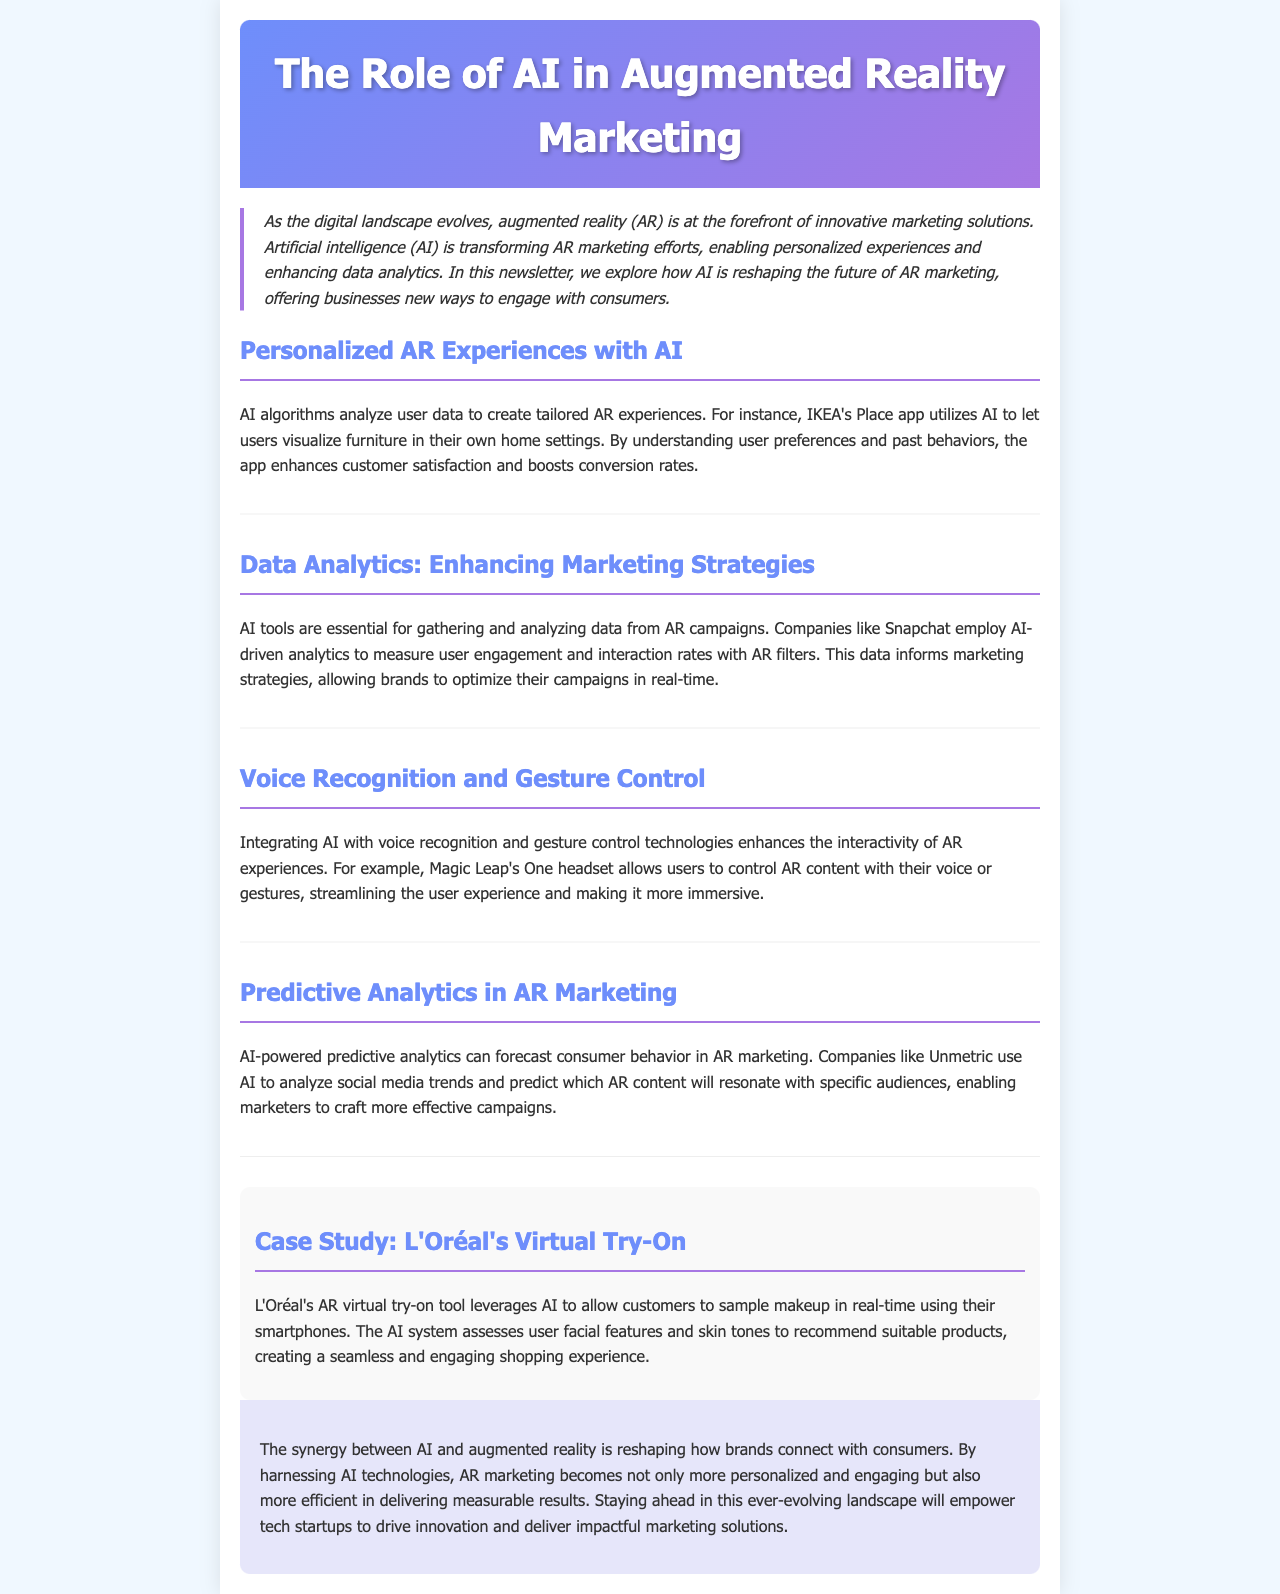What is the title of the newsletter? The title of the newsletter is presented in the header section of the document.
Answer: The Role of AI in Augmented Reality Marketing What app does IKEA utilize for personalized AR experiences? The document mentions that IKEA's Place app uses AI for creating tailored AR experiences.
Answer: Place Which company is highlighted for using AI-driven analytics in AR campaigns? The text states that Snapchat employs AI for measuring user engagement in AR filters.
Answer: Snapchat What feature does Magic Leap's One headset integrate for user interaction? The document details that the headset incorporates voice recognition and gesture control to enhance AR experiences.
Answer: Voice recognition and gesture control What specific technique does L'Oréal's AR virtual try-on tool use? The case study mentions that L'Oréal's tool leverages AI to assess user facial features and skin tones for product recommendations.
Answer: AI What type of data does AI gather to enhance marketing strategies? The document specifies that AI tools gather and analyze data from AR campaigns to inform marketing strategies.
Answer: Data Which aspect of consumer behavior does AI-powered predictive analytics forecast? The document explains that predictive analytics can forecast consumer behavior in AR marketing.
Answer: Consumer behavior What is the main benefit of combining AI with AR in marketing according to the conclusion? The conclusion states that the synergy between AI and AR creates more personalized and engaging marketing.
Answer: Personalized and engaging 